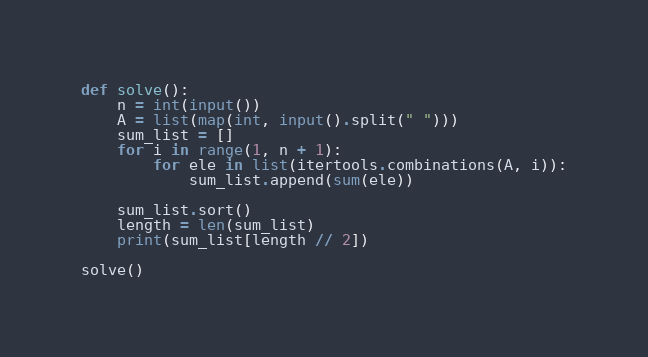Convert code to text. <code><loc_0><loc_0><loc_500><loc_500><_Python_>def solve():
    n = int(input())
    A = list(map(int, input().split(" ")))
    sum_list = []
    for i in range(1, n + 1):
        for ele in list(itertools.combinations(A, i)):
            sum_list.append(sum(ele))

    sum_list.sort()
    length = len(sum_list)
    print(sum_list[length // 2])

solve()</code> 